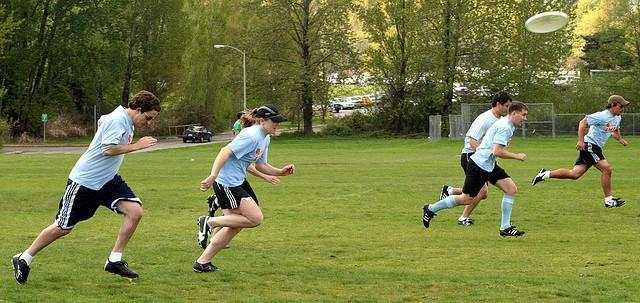How many people are there?
Give a very brief answer. 5. 